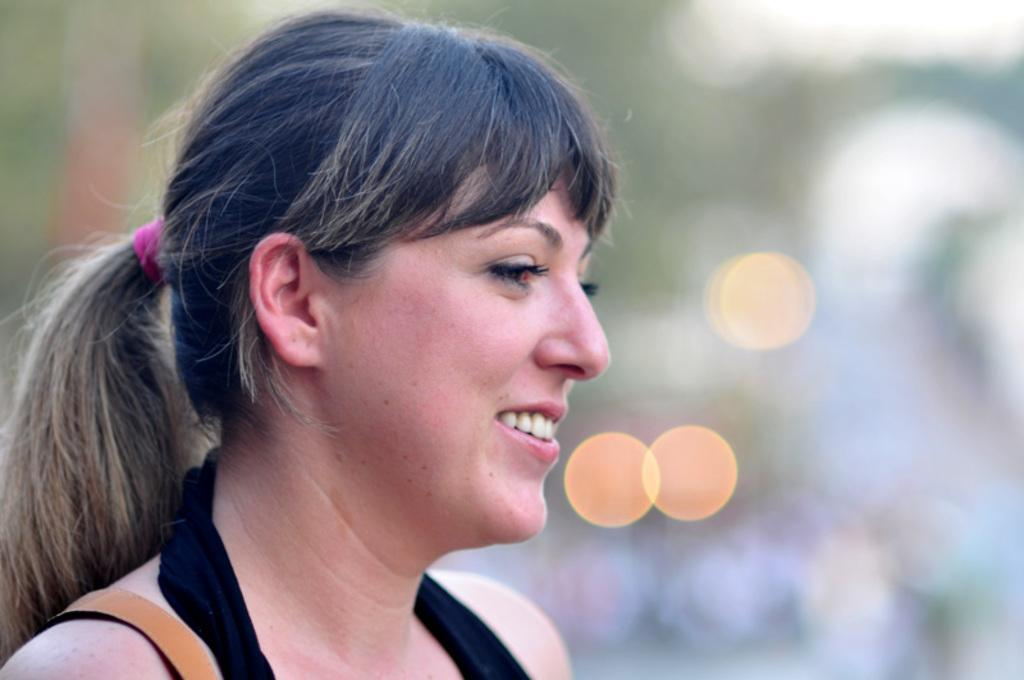What is the main subject of the image? There is a woman in the image. What is the woman doing in the image? The woman is smiling. How many snails can be seen crawling on the woman's face in the image? There are no snails present in the image. What type of baby is the woman holding in the image? There is no baby present in the image. 